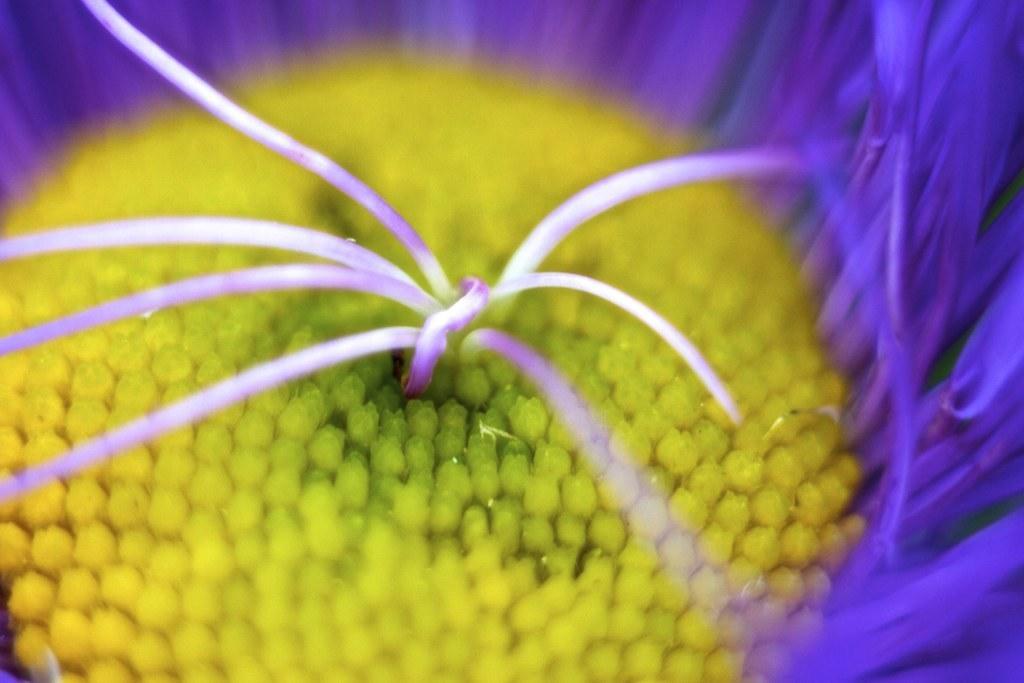In one or two sentences, can you explain what this image depicts? In this picture we can see a flower with violet color petals. 